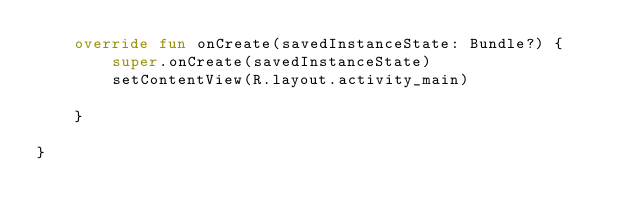Convert code to text. <code><loc_0><loc_0><loc_500><loc_500><_Kotlin_>    override fun onCreate(savedInstanceState: Bundle?) {
        super.onCreate(savedInstanceState)
        setContentView(R.layout.activity_main)

    }

}</code> 